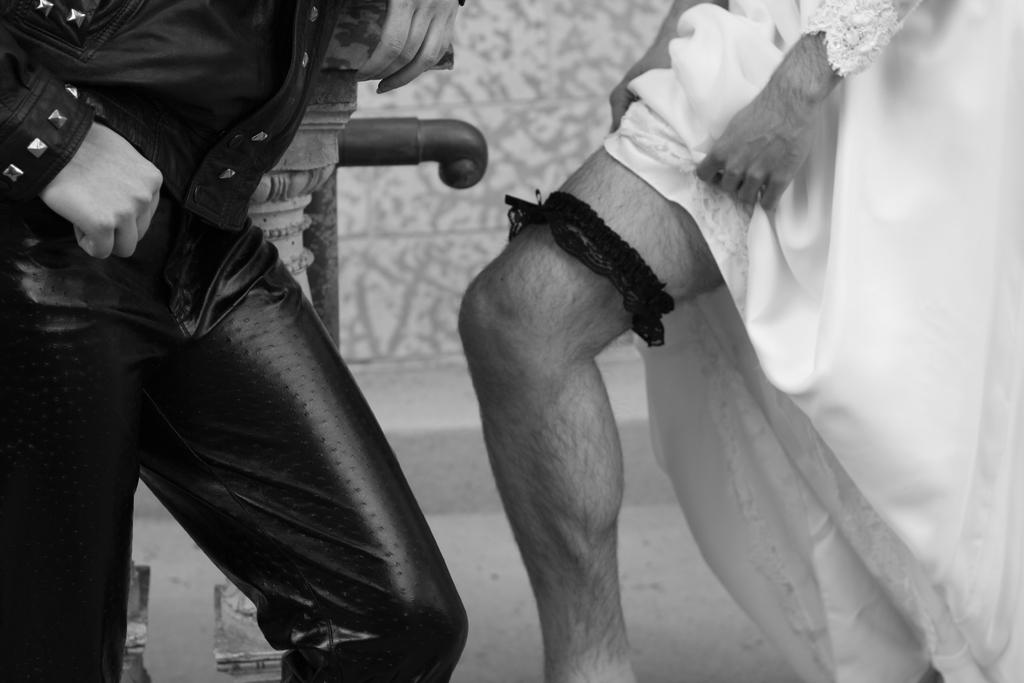How many persons are visible in the image based on their legs? There are legs of two persons visible in the image. What can be inferred about the person on the left side based on their clothing? One person is wearing a black color jacket and pant on the left side. What type of books can be seen in the library in the image? There is no library or books present in the image; it only shows the legs of two persons. 